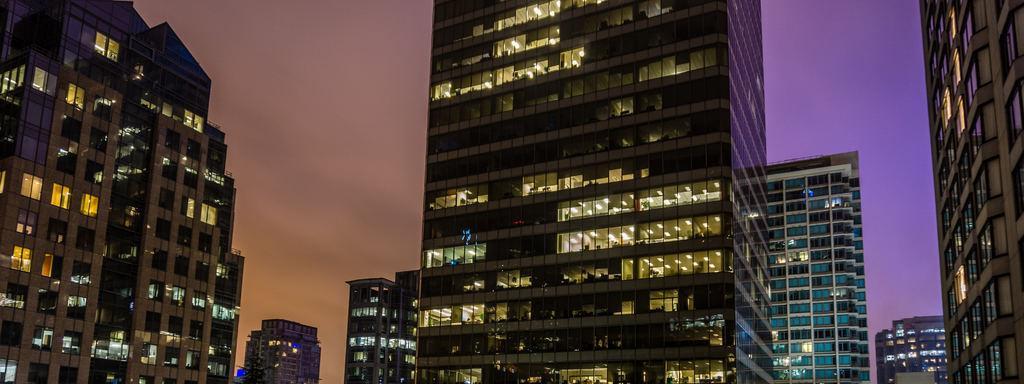How would you summarize this image in a sentence or two? In this picture we can see buildings, lights, windows, sky. 